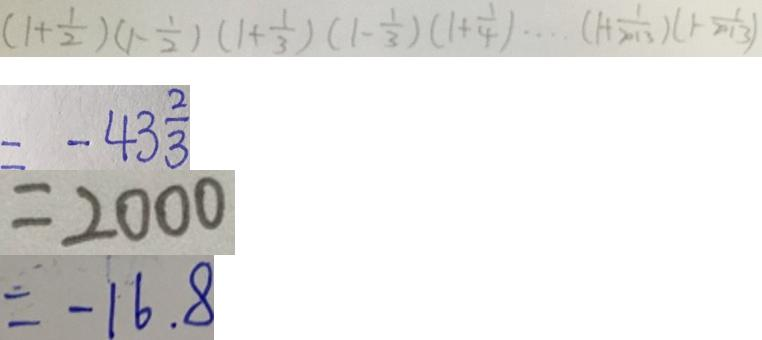<formula> <loc_0><loc_0><loc_500><loc_500>( 1 + \frac { 1 } { 2 } ) ( 1 - \frac { 1 } { 2 } ) ( 1 + \frac { 1 } { 3 } ) ( 1 - \frac { 1 } { 3 } ) ( 1 + \frac { 1 } { 4 } ) \cdots ( 1 + \frac { 1 } { 2 0 1 3 } ) ( 1 - \frac { 1 } { 2 0 1 3 } ) 
 = - 4 3 \frac { 2 } { 3 } 
 = 2 0 0 0 
 = - 1 6 . 8</formula> 